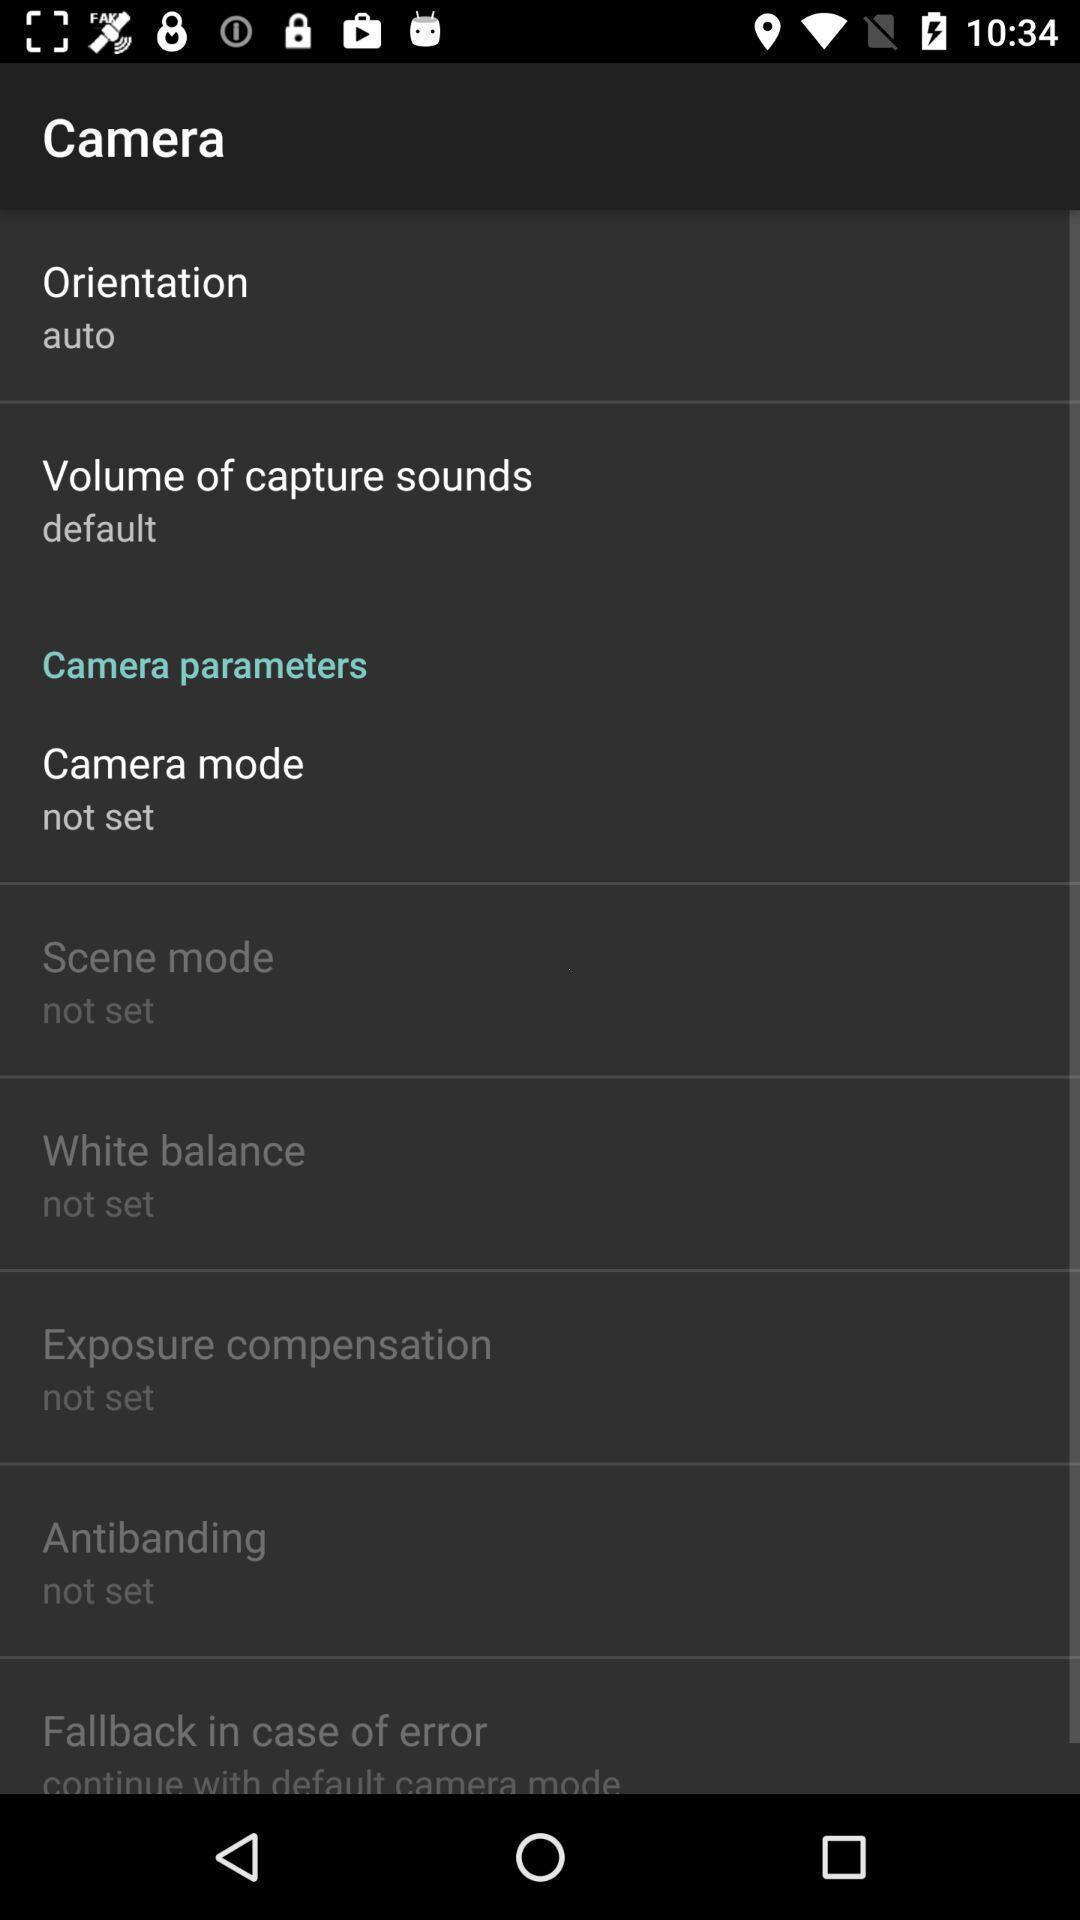Describe the key features of this screenshot. Settings page of a camera app. 